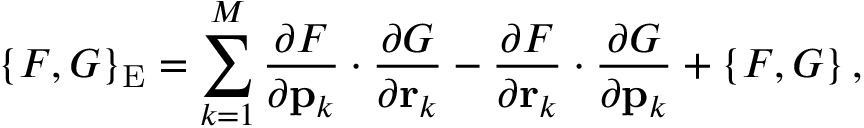Convert formula to latex. <formula><loc_0><loc_0><loc_500><loc_500>\left \{ F , G \right \} _ { E } = \sum _ { k = 1 } ^ { M } { \frac { \partial F } { \partial { p } _ { k } } \cdot \frac { \partial G } { \partial { r } _ { k } } - \frac { \partial F } { \partial { r } _ { k } } \cdot \frac { \partial G } { \partial { p } _ { k } } } + \left \{ F , G \right \} ,</formula> 